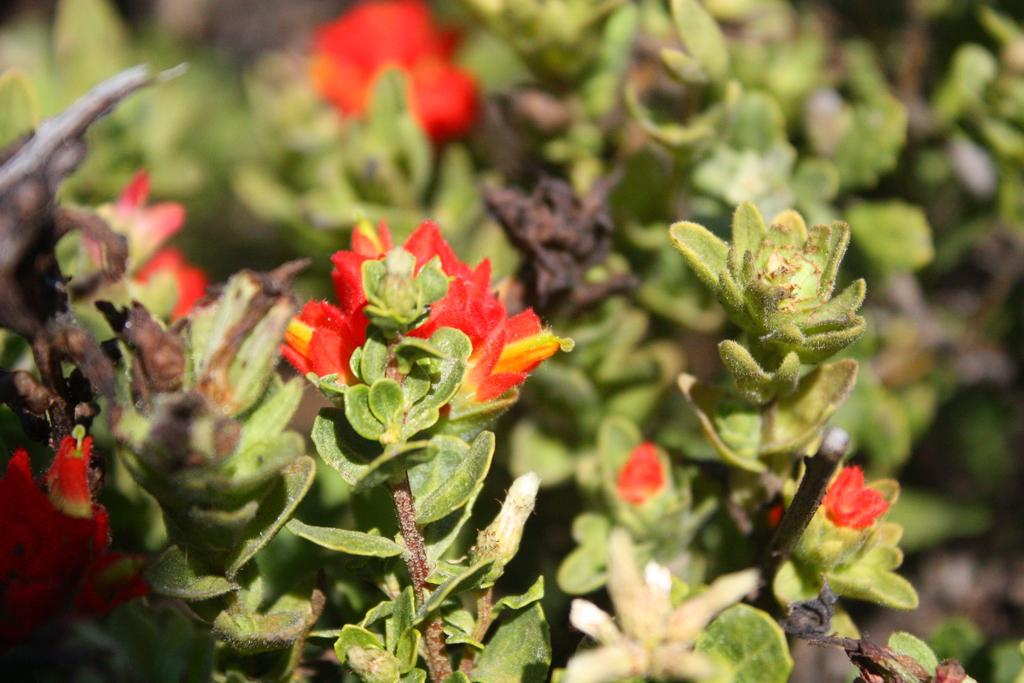What type of plants are present in the image? There are plants with flowers in the image. What color are the flowers on the plants? The flowers are red in color. Can you describe the background of the image? The background of the image has red and green colors, and it is blurred. How many brothers are depicted in the image? There are no people, including brothers, present in the image; it features plants with red flowers and a blurred background. 